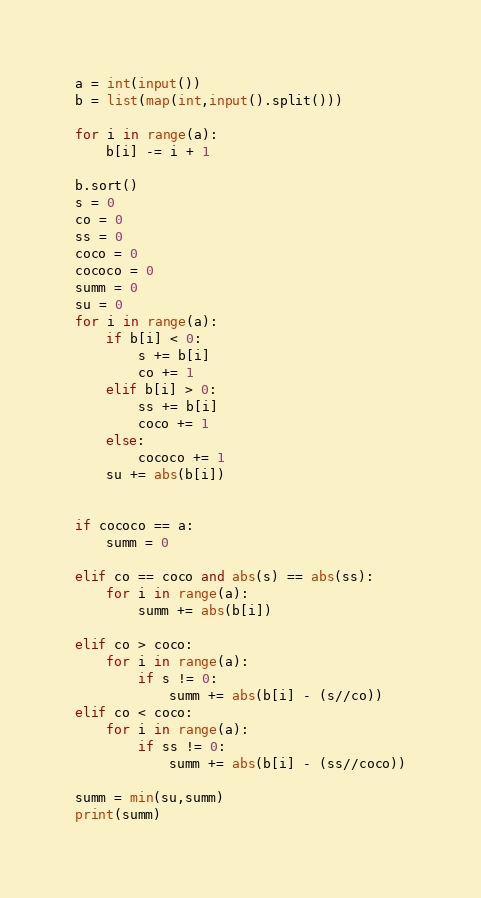<code> <loc_0><loc_0><loc_500><loc_500><_Python_>a = int(input())
b = list(map(int,input().split()))

for i in range(a):
	b[i] -= i + 1

b.sort()
s = 0
co = 0
ss = 0
coco = 0
cococo = 0
summ = 0
su = 0
for i in range(a):
	if b[i] < 0:
		s += b[i]
		co += 1
	elif b[i] > 0:
		ss += b[i]
		coco += 1
	else:
		cococo += 1
	su += abs(b[i])


if cococo == a:
	summ = 0

elif co == coco and abs(s) == abs(ss):
	for i in range(a):
		summ += abs(b[i])

elif co > coco:
	for i in range(a):
		if s != 0:
			summ += abs(b[i] - (s//co))
elif co < coco:
	for i in range(a):
		if ss != 0:
			summ += abs(b[i] - (ss//coco))

summ = min(su,summ)
print(summ)

</code> 